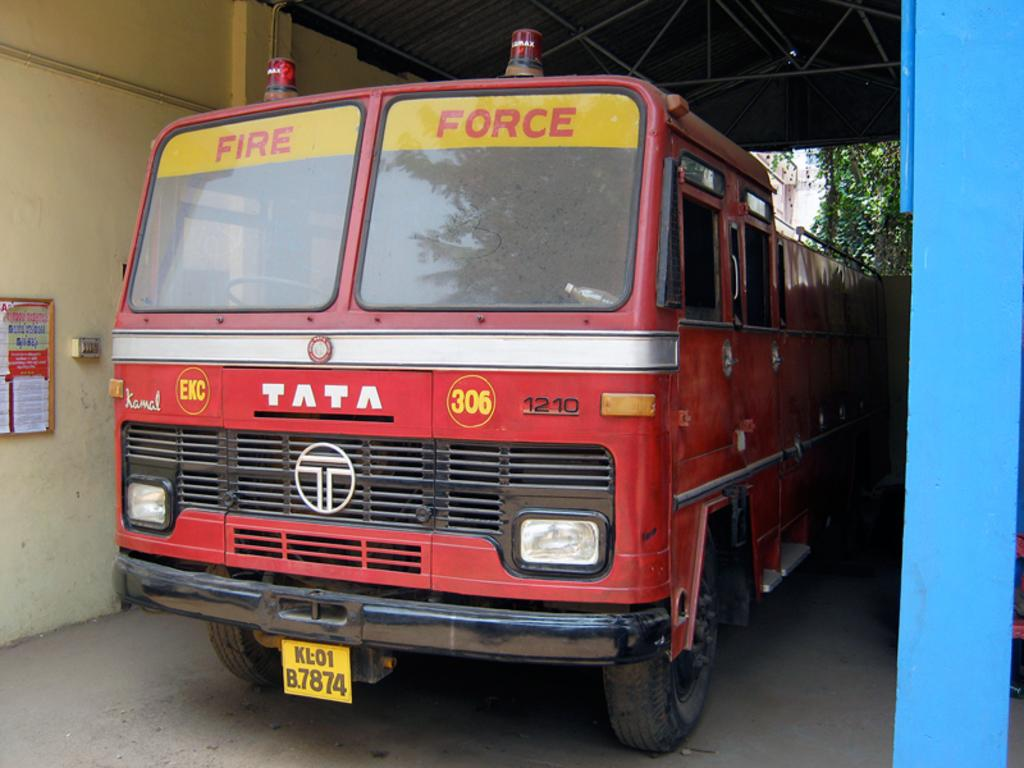What is located under the shed in the image? There is a vehicle under the shed in the image. What can be seen on the left side of the image? There is a wall on the left side of the image. What is visible in the background of the image? There are trees and a building in the background of the image. What is the color of the pillar on the right side of the image? There is a blue color pillar on the right side of the image. Are there any dinosaurs visible in the image? No, there are no dinosaurs present in the image. What type of calculator can be seen on the vehicle under the shed? There is no calculator visible in the image, as it does not mention any calculator in the provided facts. 